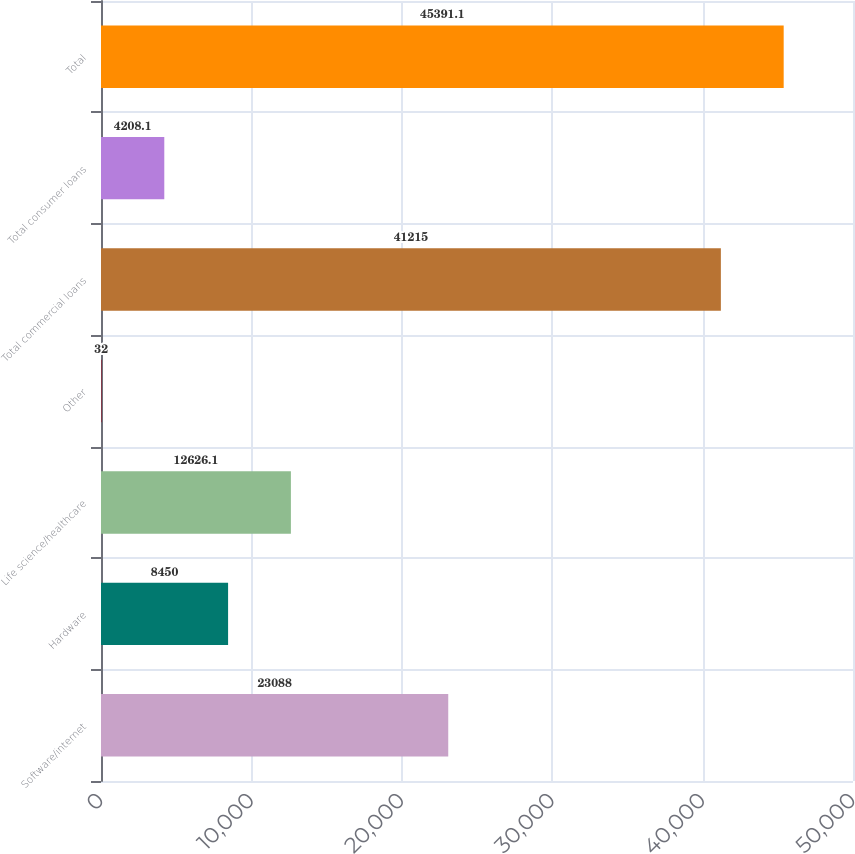Convert chart to OTSL. <chart><loc_0><loc_0><loc_500><loc_500><bar_chart><fcel>Software/internet<fcel>Hardware<fcel>Life science/healthcare<fcel>Other<fcel>Total commercial loans<fcel>Total consumer loans<fcel>Total<nl><fcel>23088<fcel>8450<fcel>12626.1<fcel>32<fcel>41215<fcel>4208.1<fcel>45391.1<nl></chart> 